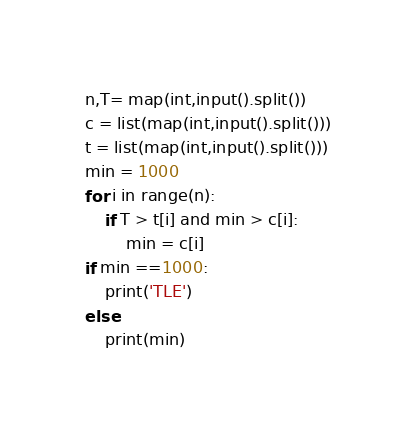<code> <loc_0><loc_0><loc_500><loc_500><_Python_>n,T= map(int,input().split())
c = list(map(int,input().split()))
t = list(map(int,input().split()))
min = 1000
for i in range(n):
    if T > t[i] and min > c[i]:
        min = c[i]
if min ==1000:
    print('TLE')
else:
    print(min)
</code> 